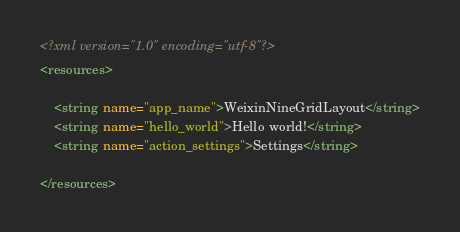<code> <loc_0><loc_0><loc_500><loc_500><_XML_><?xml version="1.0" encoding="utf-8"?>
<resources>

    <string name="app_name">WeixinNineGridLayout</string>
    <string name="hello_world">Hello world!</string>
    <string name="action_settings">Settings</string>

</resources>
</code> 